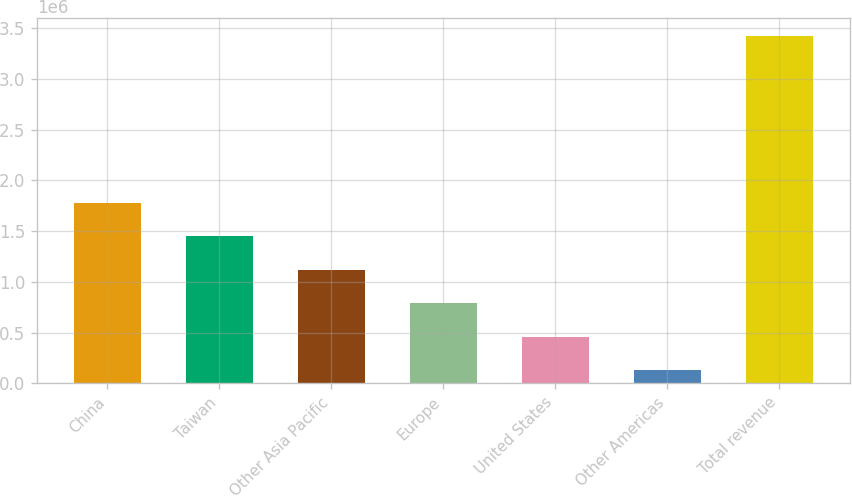<chart> <loc_0><loc_0><loc_500><loc_500><bar_chart><fcel>China<fcel>Taiwan<fcel>Other Asia Pacific<fcel>Europe<fcel>United States<fcel>Other Americas<fcel>Total revenue<nl><fcel>1.77788e+06<fcel>1.44849e+06<fcel>1.11909e+06<fcel>789697<fcel>460301<fcel>130906<fcel>3.42486e+06<nl></chart> 